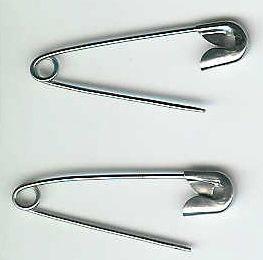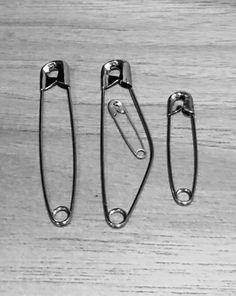The first image is the image on the left, the second image is the image on the right. Evaluate the accuracy of this statement regarding the images: "The two pins in the image on the left are not touching each other.". Is it true? Answer yes or no. Yes. The first image is the image on the left, the second image is the image on the right. For the images shown, is this caption "An image contains exactly two safety pins, displayed one above the other, and not overlapping." true? Answer yes or no. Yes. 